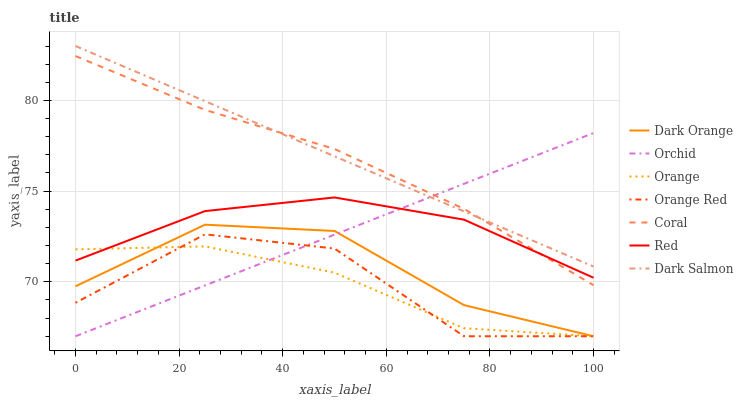Does Orange have the minimum area under the curve?
Answer yes or no. Yes. Does Dark Salmon have the maximum area under the curve?
Answer yes or no. Yes. Does Coral have the minimum area under the curve?
Answer yes or no. No. Does Coral have the maximum area under the curve?
Answer yes or no. No. Is Dark Salmon the smoothest?
Answer yes or no. Yes. Is Orange Red the roughest?
Answer yes or no. Yes. Is Coral the smoothest?
Answer yes or no. No. Is Coral the roughest?
Answer yes or no. No. Does Dark Orange have the lowest value?
Answer yes or no. Yes. Does Coral have the lowest value?
Answer yes or no. No. Does Dark Salmon have the highest value?
Answer yes or no. Yes. Does Coral have the highest value?
Answer yes or no. No. Is Orange less than Dark Salmon?
Answer yes or no. Yes. Is Dark Salmon greater than Orange Red?
Answer yes or no. Yes. Does Orchid intersect Red?
Answer yes or no. Yes. Is Orchid less than Red?
Answer yes or no. No. Is Orchid greater than Red?
Answer yes or no. No. Does Orange intersect Dark Salmon?
Answer yes or no. No. 